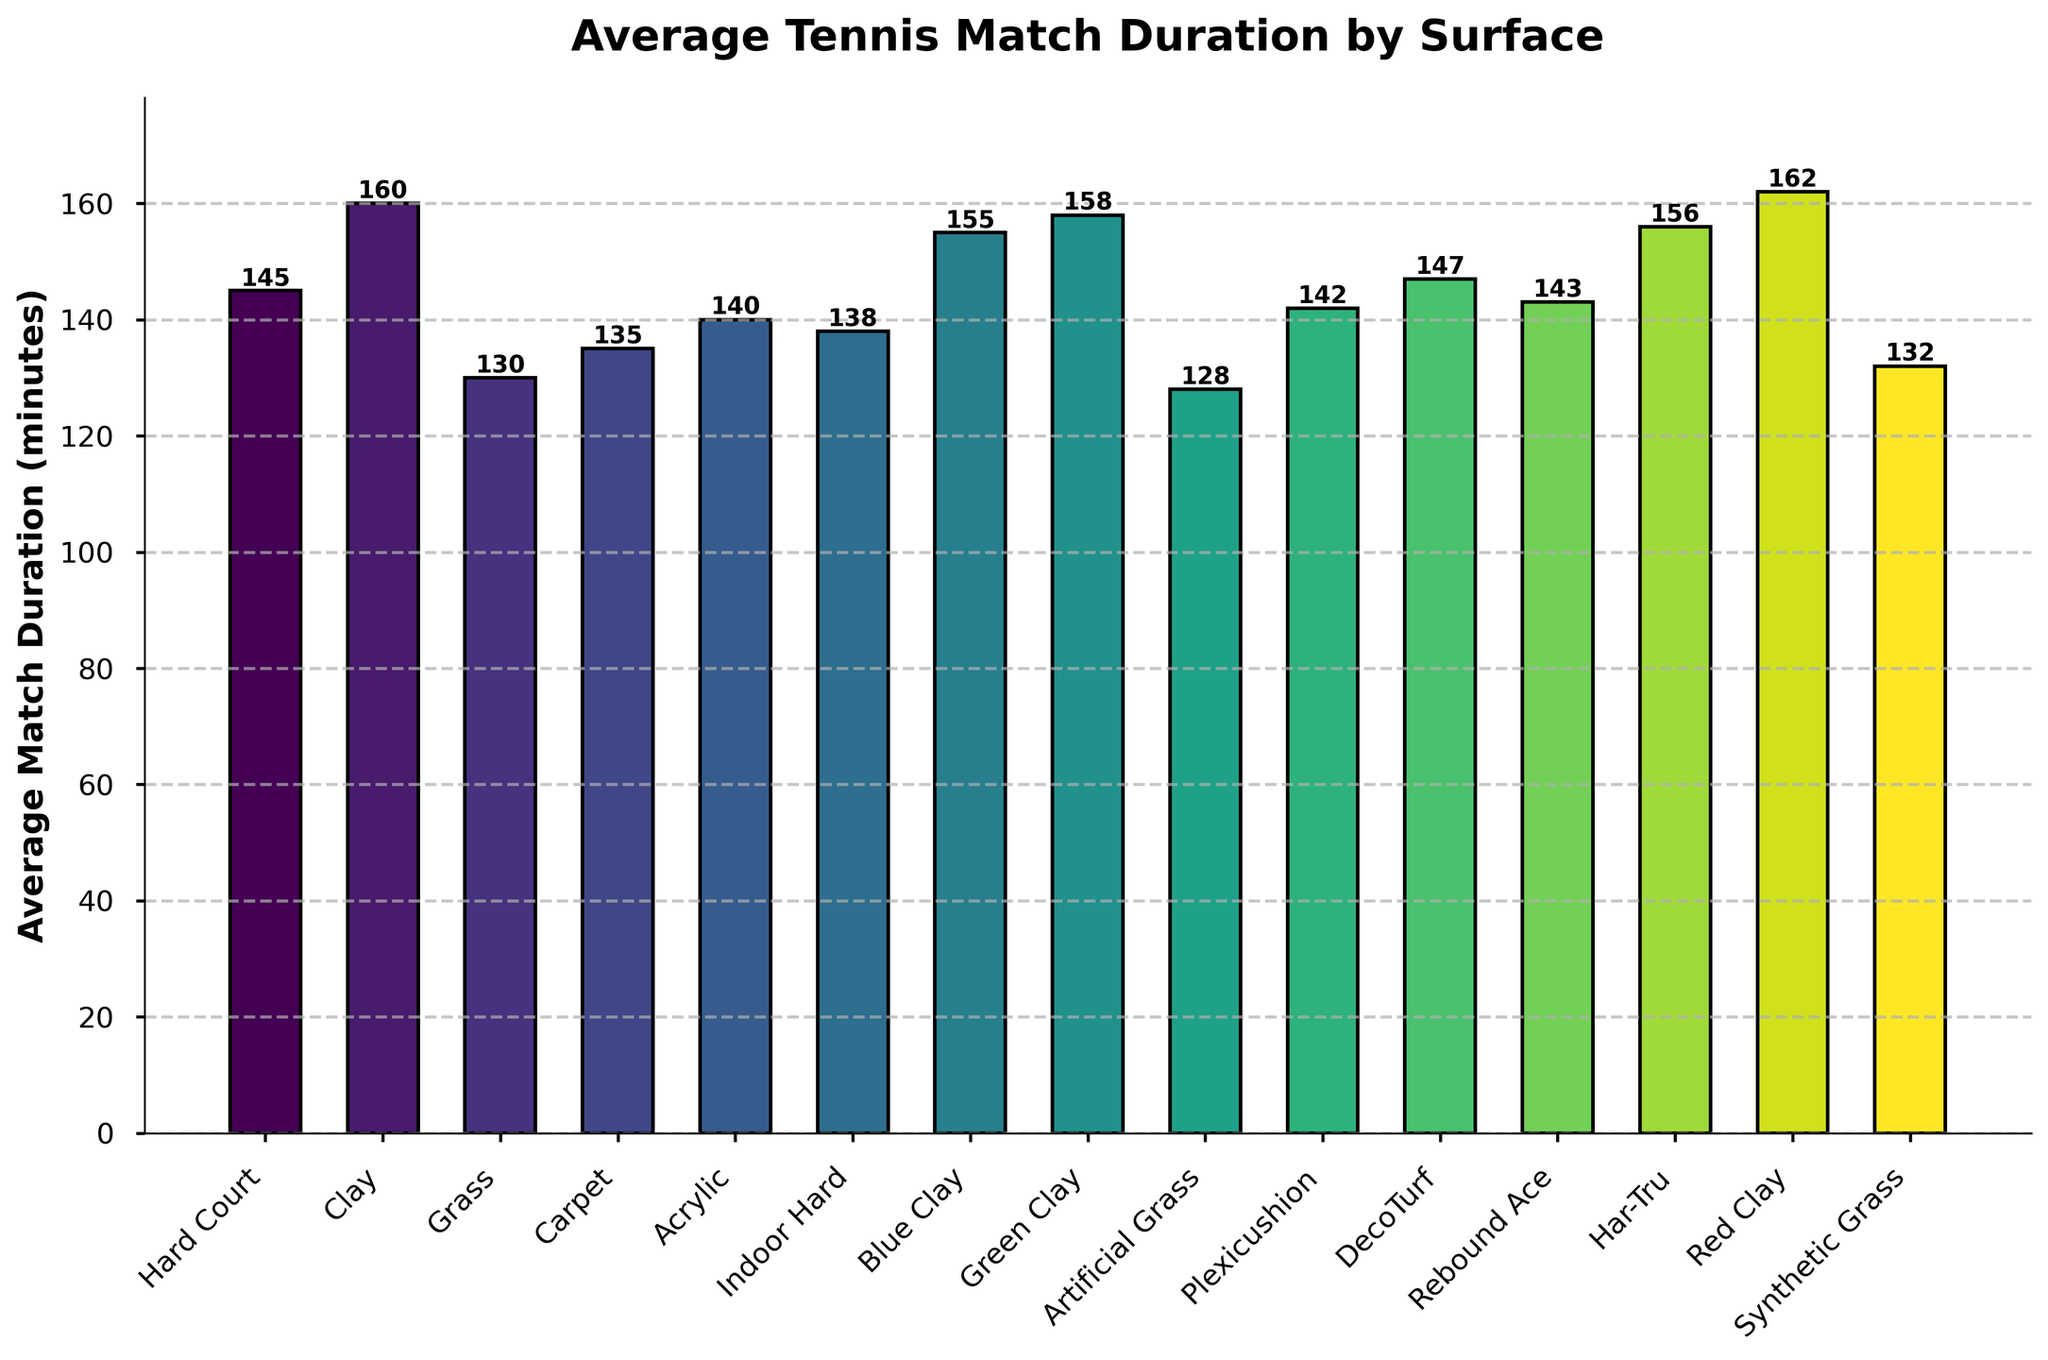What's the longest average match duration surface? The data shows the average match duration for each surface. The longest duration is on the Red Clay surface with 162 minutes.
Answer: Red Clay Which surface has the shortest average match duration? By comparing all the bars, the shortest average match duration is on Artificial Grass with 128 minutes.
Answer: Artificial Grass What is the difference in average match duration between Clay and Grass surfaces? The average match duration for Clay is 160 minutes, and for Grass, it is 130 minutes. The difference is 160 - 130 = 30 minutes.
Answer: 30 minutes How many surfaces have an average match duration longer than 150 minutes? The surfaces with average match durations longer than 150 minutes are Clay (160), Blue Clay (155), Green Clay (158), Har-Tru (156), Red Clay (162). There are 5 such surfaces.
Answer: 5 Which surface types have average match durations within 5 minutes of each other? Green Clay (158), Har-Tru (156), and Blue Clay (155) have average match durations within 5 minutes of each other.
Answer: Green Clay, Har-Tru, Blue Clay Which two surfaces have the most similar average match duration? The average match durations for Har-Tru (156) and Green Clay (158) are the most similar, with only a 2 minutes difference.
Answer: Har-Tru and Green Clay What is the total average match duration for all surfaces combined? Summing all the average match durations: 145 + 160 + 130 + 135 + 140 + 138 + 155 + 158 + 128 + 142 + 147 + 143 + 156 + 162 + 132 = 2271 minutes.
Answer: 2271 minutes What is the average match duration across all surfaces? Total sum of durations is 2271, and there are 15 surfaces. The average duration is 2271 / 15 ≈ 151.4 minutes.
Answer: 151.4 minutes By how much does the average match duration on Blue Clay exceed that on Plexicushion? Blue Clay has an average match duration of 155 minutes, while Plexicushion has 142 minutes. The difference is 155 - 142 = 13 minutes.
Answer: 13 minutes 